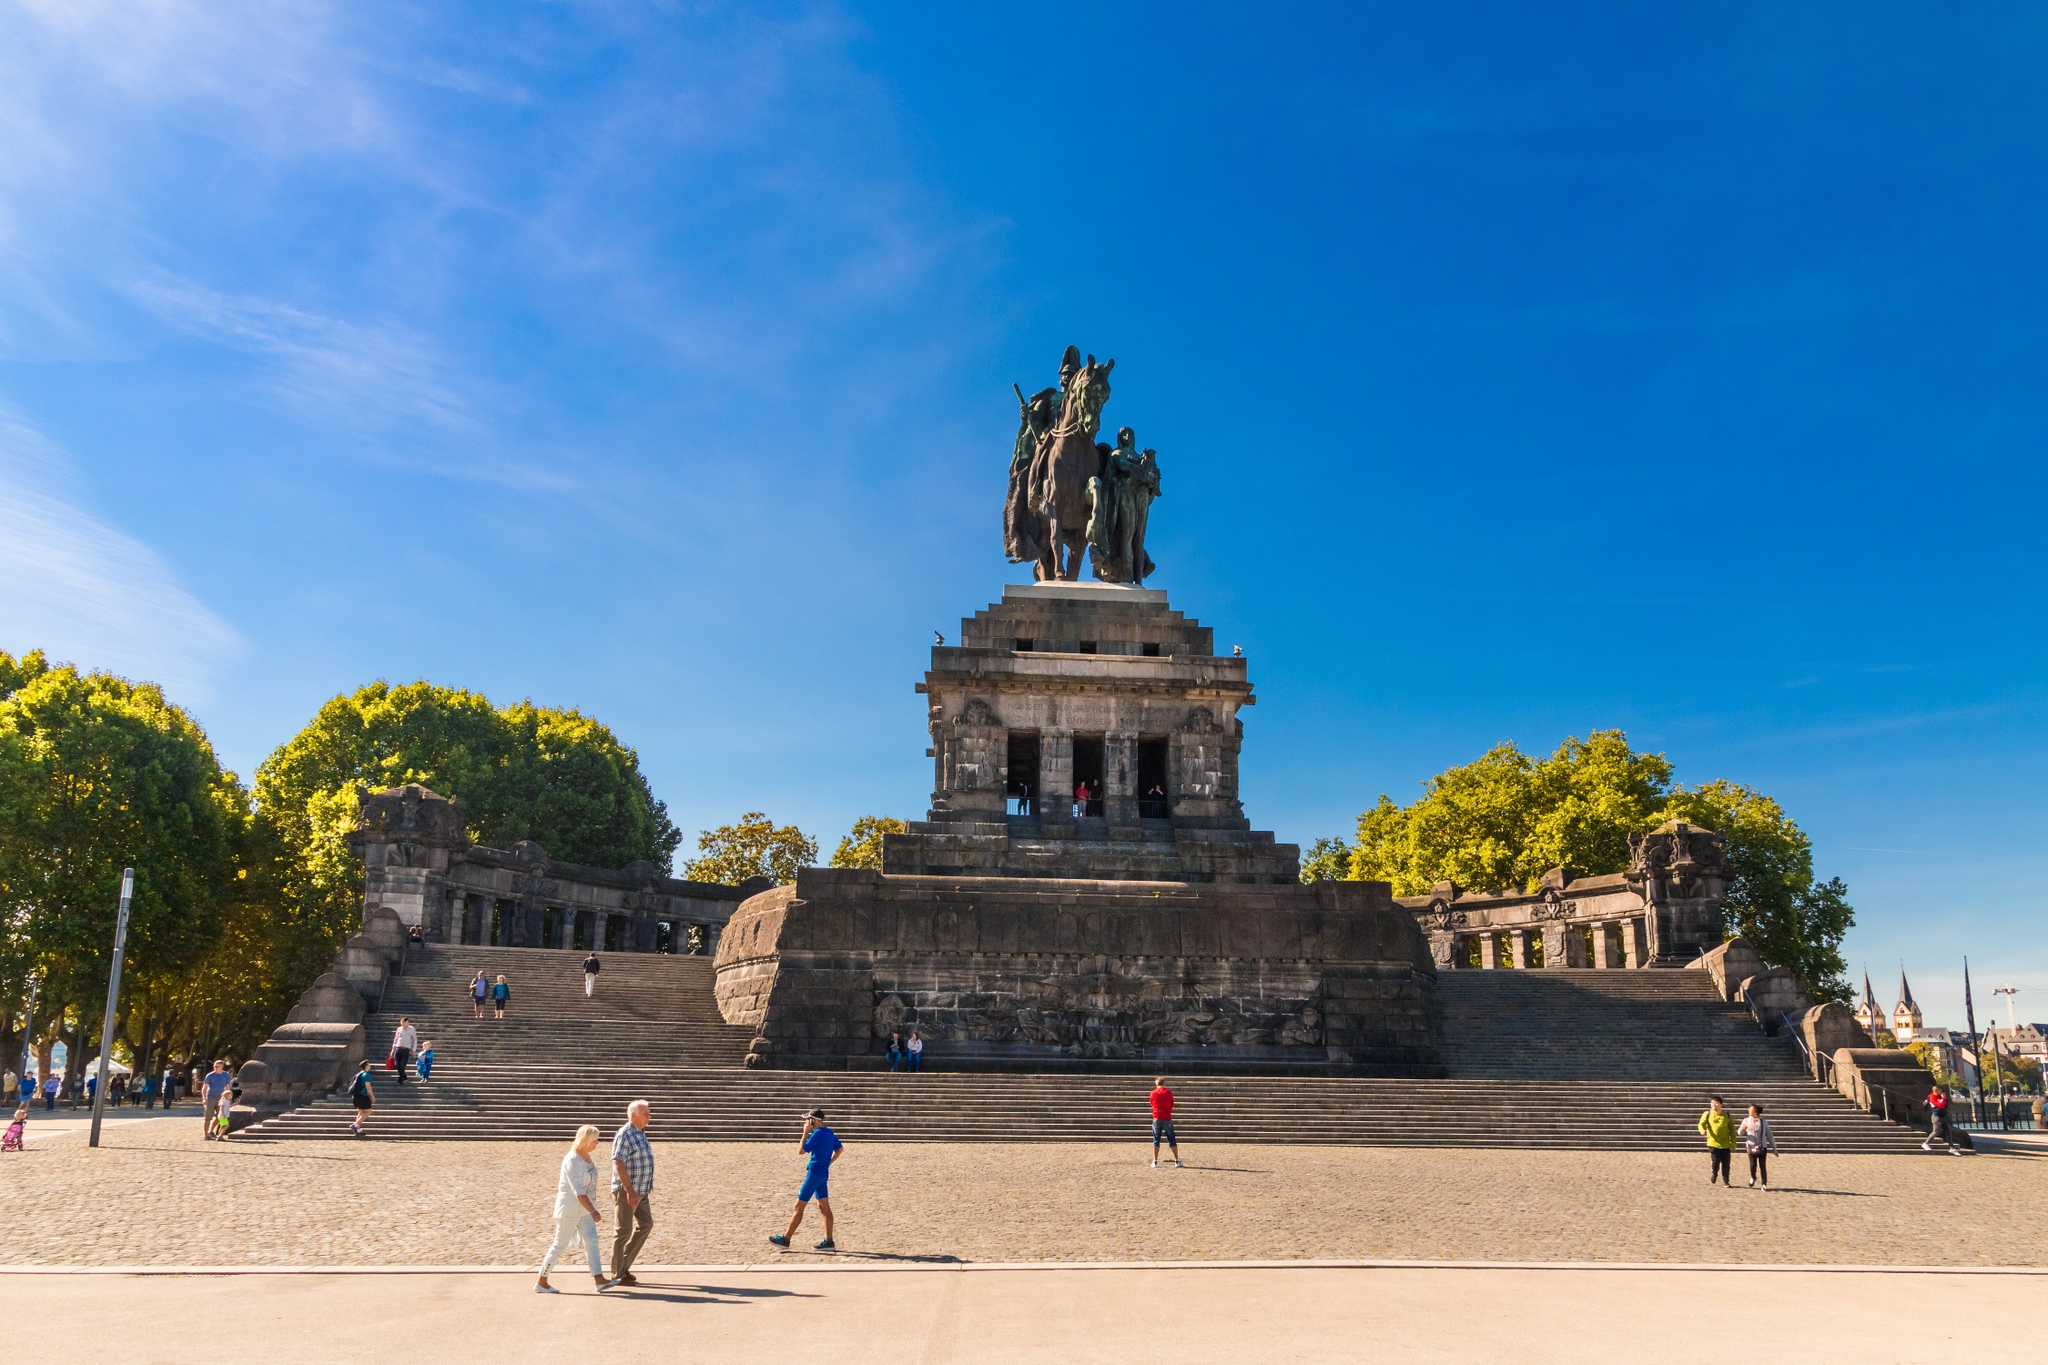Why is the equestrian statue significant? Equestrian statues have long been symbols of power and authority. The statue of William I at Deutsches Eck is especially significant because it commemorates the first Emperor of a unified Germany. His leadership during periods of political upheaval solidified his legacy as a unifying figure. The statue, therefore, is not just an impressive piece of art but a national symbol of unity and strength. 